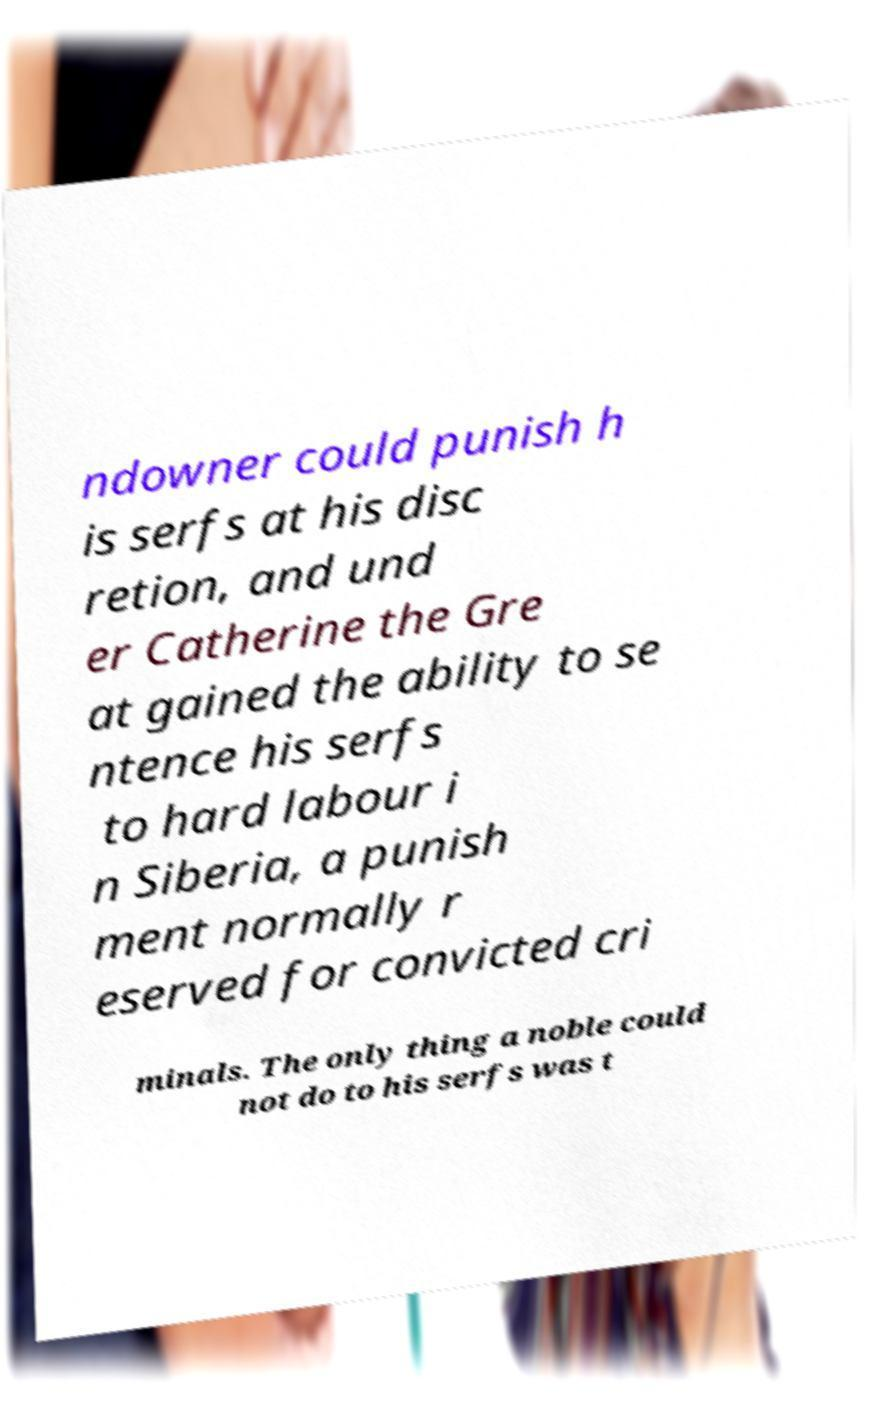There's text embedded in this image that I need extracted. Can you transcribe it verbatim? ndowner could punish h is serfs at his disc retion, and und er Catherine the Gre at gained the ability to se ntence his serfs to hard labour i n Siberia, a punish ment normally r eserved for convicted cri minals. The only thing a noble could not do to his serfs was t 